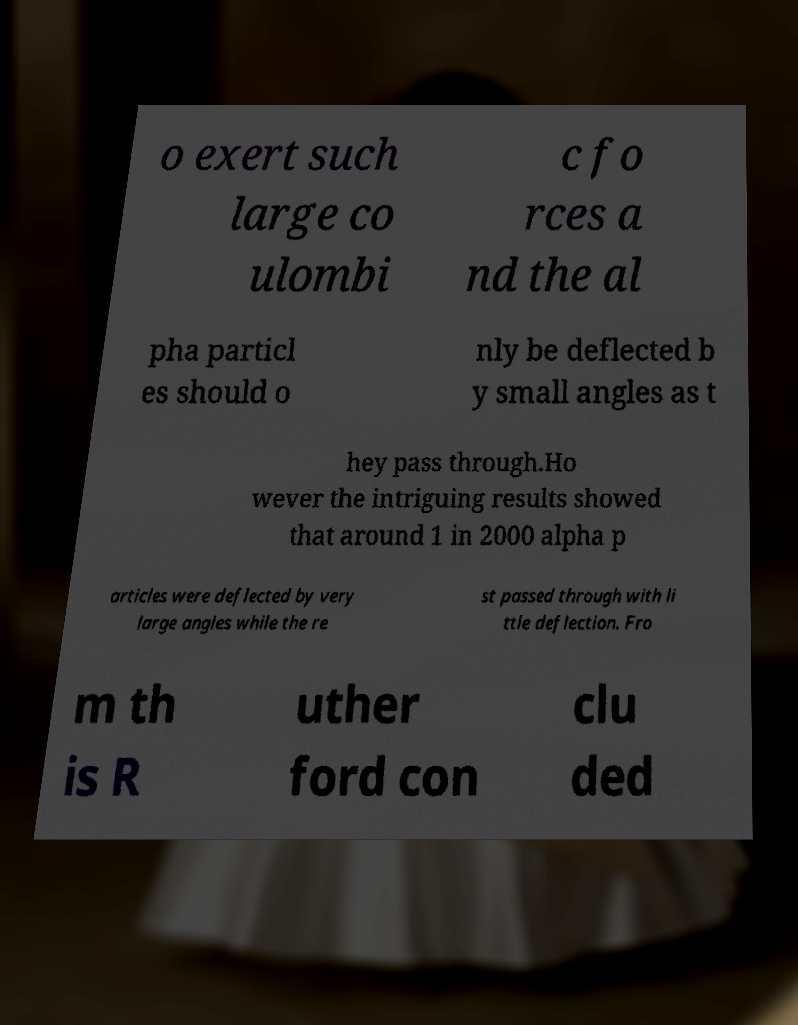Can you read and provide the text displayed in the image?This photo seems to have some interesting text. Can you extract and type it out for me? o exert such large co ulombi c fo rces a nd the al pha particl es should o nly be deflected b y small angles as t hey pass through.Ho wever the intriguing results showed that around 1 in 2000 alpha p articles were deflected by very large angles while the re st passed through with li ttle deflection. Fro m th is R uther ford con clu ded 